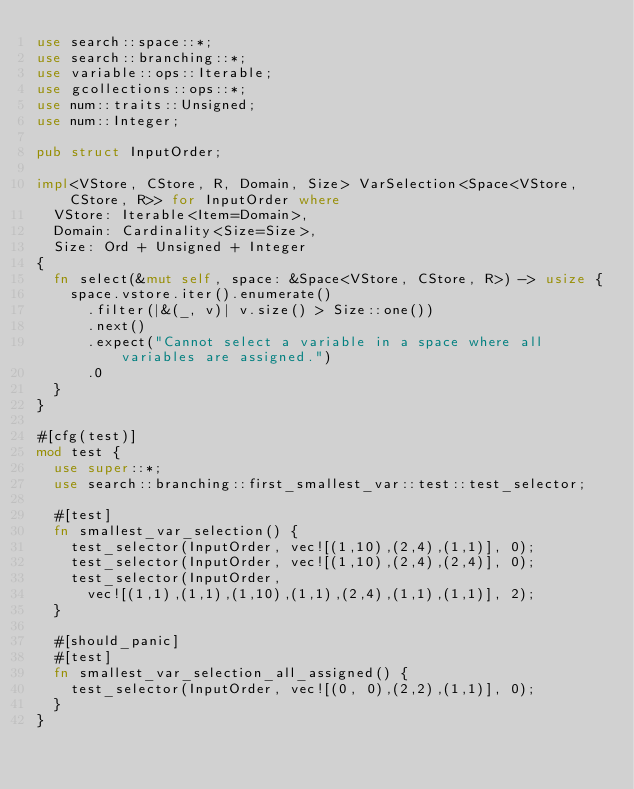Convert code to text. <code><loc_0><loc_0><loc_500><loc_500><_Rust_>use search::space::*;
use search::branching::*;
use variable::ops::Iterable;
use gcollections::ops::*;
use num::traits::Unsigned;
use num::Integer;

pub struct InputOrder;

impl<VStore, CStore, R, Domain, Size> VarSelection<Space<VStore, CStore, R>> for InputOrder where
  VStore: Iterable<Item=Domain>,
  Domain: Cardinality<Size=Size>,
  Size: Ord + Unsigned + Integer
{
  fn select(&mut self, space: &Space<VStore, CStore, R>) -> usize {
    space.vstore.iter().enumerate()
      .filter(|&(_, v)| v.size() > Size::one())
      .next()
      .expect("Cannot select a variable in a space where all variables are assigned.")
      .0
  }
}

#[cfg(test)]
mod test {
  use super::*;
  use search::branching::first_smallest_var::test::test_selector;

  #[test]
  fn smallest_var_selection() {
    test_selector(InputOrder, vec![(1,10),(2,4),(1,1)], 0);
    test_selector(InputOrder, vec![(1,10),(2,4),(2,4)], 0);
    test_selector(InputOrder,
      vec![(1,1),(1,1),(1,10),(1,1),(2,4),(1,1),(1,1)], 2);
  }

  #[should_panic]
  #[test]
  fn smallest_var_selection_all_assigned() {
    test_selector(InputOrder, vec![(0, 0),(2,2),(1,1)], 0);
  }
}
</code> 